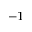Convert formula to latex. <formula><loc_0><loc_0><loc_500><loc_500>^ { - 1 }</formula> 